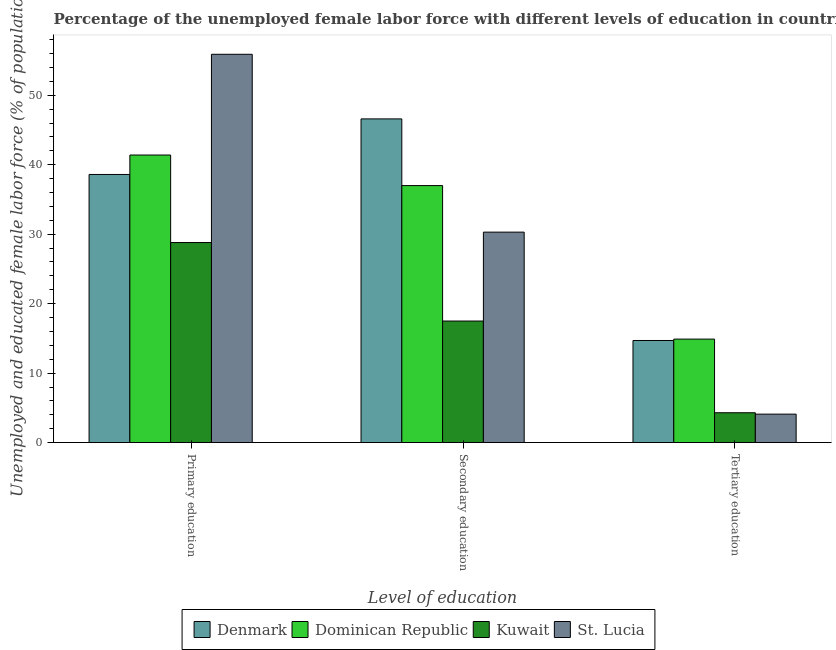Are the number of bars on each tick of the X-axis equal?
Your answer should be compact. Yes. How many bars are there on the 1st tick from the left?
Make the answer very short. 4. How many bars are there on the 2nd tick from the right?
Keep it short and to the point. 4. What is the label of the 3rd group of bars from the left?
Provide a succinct answer. Tertiary education. What is the percentage of female labor force who received tertiary education in Dominican Republic?
Give a very brief answer. 14.9. Across all countries, what is the maximum percentage of female labor force who received tertiary education?
Make the answer very short. 14.9. Across all countries, what is the minimum percentage of female labor force who received tertiary education?
Offer a terse response. 4.1. In which country was the percentage of female labor force who received secondary education maximum?
Your answer should be very brief. Denmark. In which country was the percentage of female labor force who received secondary education minimum?
Give a very brief answer. Kuwait. What is the total percentage of female labor force who received tertiary education in the graph?
Ensure brevity in your answer.  38. What is the difference between the percentage of female labor force who received secondary education in Dominican Republic and that in St. Lucia?
Offer a very short reply. 6.7. What is the difference between the percentage of female labor force who received tertiary education in St. Lucia and the percentage of female labor force who received primary education in Kuwait?
Keep it short and to the point. -24.7. What is the average percentage of female labor force who received secondary education per country?
Make the answer very short. 32.85. What is the difference between the percentage of female labor force who received secondary education and percentage of female labor force who received tertiary education in Dominican Republic?
Offer a very short reply. 22.1. What is the ratio of the percentage of female labor force who received secondary education in Dominican Republic to that in St. Lucia?
Provide a succinct answer. 1.22. What is the difference between the highest and the lowest percentage of female labor force who received tertiary education?
Make the answer very short. 10.8. In how many countries, is the percentage of female labor force who received secondary education greater than the average percentage of female labor force who received secondary education taken over all countries?
Offer a terse response. 2. What does the 4th bar from the right in Tertiary education represents?
Ensure brevity in your answer.  Denmark. Are all the bars in the graph horizontal?
Ensure brevity in your answer.  No. How many countries are there in the graph?
Make the answer very short. 4. Does the graph contain grids?
Your answer should be very brief. No. Where does the legend appear in the graph?
Your answer should be very brief. Bottom center. How many legend labels are there?
Your answer should be very brief. 4. How are the legend labels stacked?
Your answer should be compact. Horizontal. What is the title of the graph?
Provide a short and direct response. Percentage of the unemployed female labor force with different levels of education in countries. What is the label or title of the X-axis?
Offer a very short reply. Level of education. What is the label or title of the Y-axis?
Provide a succinct answer. Unemployed and educated female labor force (% of population). What is the Unemployed and educated female labor force (% of population) in Denmark in Primary education?
Keep it short and to the point. 38.6. What is the Unemployed and educated female labor force (% of population) in Dominican Republic in Primary education?
Provide a short and direct response. 41.4. What is the Unemployed and educated female labor force (% of population) in Kuwait in Primary education?
Ensure brevity in your answer.  28.8. What is the Unemployed and educated female labor force (% of population) in St. Lucia in Primary education?
Keep it short and to the point. 55.9. What is the Unemployed and educated female labor force (% of population) of Denmark in Secondary education?
Your answer should be very brief. 46.6. What is the Unemployed and educated female labor force (% of population) of Dominican Republic in Secondary education?
Provide a succinct answer. 37. What is the Unemployed and educated female labor force (% of population) of St. Lucia in Secondary education?
Your answer should be very brief. 30.3. What is the Unemployed and educated female labor force (% of population) in Denmark in Tertiary education?
Provide a short and direct response. 14.7. What is the Unemployed and educated female labor force (% of population) of Dominican Republic in Tertiary education?
Give a very brief answer. 14.9. What is the Unemployed and educated female labor force (% of population) in Kuwait in Tertiary education?
Provide a short and direct response. 4.3. What is the Unemployed and educated female labor force (% of population) of St. Lucia in Tertiary education?
Provide a short and direct response. 4.1. Across all Level of education, what is the maximum Unemployed and educated female labor force (% of population) of Denmark?
Your answer should be very brief. 46.6. Across all Level of education, what is the maximum Unemployed and educated female labor force (% of population) of Dominican Republic?
Provide a short and direct response. 41.4. Across all Level of education, what is the maximum Unemployed and educated female labor force (% of population) in Kuwait?
Offer a very short reply. 28.8. Across all Level of education, what is the maximum Unemployed and educated female labor force (% of population) in St. Lucia?
Ensure brevity in your answer.  55.9. Across all Level of education, what is the minimum Unemployed and educated female labor force (% of population) in Denmark?
Provide a succinct answer. 14.7. Across all Level of education, what is the minimum Unemployed and educated female labor force (% of population) of Dominican Republic?
Your response must be concise. 14.9. Across all Level of education, what is the minimum Unemployed and educated female labor force (% of population) of Kuwait?
Your answer should be compact. 4.3. Across all Level of education, what is the minimum Unemployed and educated female labor force (% of population) in St. Lucia?
Give a very brief answer. 4.1. What is the total Unemployed and educated female labor force (% of population) in Denmark in the graph?
Give a very brief answer. 99.9. What is the total Unemployed and educated female labor force (% of population) in Dominican Republic in the graph?
Your answer should be very brief. 93.3. What is the total Unemployed and educated female labor force (% of population) in Kuwait in the graph?
Give a very brief answer. 50.6. What is the total Unemployed and educated female labor force (% of population) of St. Lucia in the graph?
Ensure brevity in your answer.  90.3. What is the difference between the Unemployed and educated female labor force (% of population) in Denmark in Primary education and that in Secondary education?
Offer a terse response. -8. What is the difference between the Unemployed and educated female labor force (% of population) in St. Lucia in Primary education and that in Secondary education?
Ensure brevity in your answer.  25.6. What is the difference between the Unemployed and educated female labor force (% of population) of Denmark in Primary education and that in Tertiary education?
Make the answer very short. 23.9. What is the difference between the Unemployed and educated female labor force (% of population) of St. Lucia in Primary education and that in Tertiary education?
Give a very brief answer. 51.8. What is the difference between the Unemployed and educated female labor force (% of population) of Denmark in Secondary education and that in Tertiary education?
Your answer should be compact. 31.9. What is the difference between the Unemployed and educated female labor force (% of population) of Dominican Republic in Secondary education and that in Tertiary education?
Ensure brevity in your answer.  22.1. What is the difference between the Unemployed and educated female labor force (% of population) of St. Lucia in Secondary education and that in Tertiary education?
Offer a terse response. 26.2. What is the difference between the Unemployed and educated female labor force (% of population) of Denmark in Primary education and the Unemployed and educated female labor force (% of population) of Kuwait in Secondary education?
Provide a succinct answer. 21.1. What is the difference between the Unemployed and educated female labor force (% of population) in Denmark in Primary education and the Unemployed and educated female labor force (% of population) in St. Lucia in Secondary education?
Your response must be concise. 8.3. What is the difference between the Unemployed and educated female labor force (% of population) in Dominican Republic in Primary education and the Unemployed and educated female labor force (% of population) in Kuwait in Secondary education?
Provide a short and direct response. 23.9. What is the difference between the Unemployed and educated female labor force (% of population) in Kuwait in Primary education and the Unemployed and educated female labor force (% of population) in St. Lucia in Secondary education?
Your response must be concise. -1.5. What is the difference between the Unemployed and educated female labor force (% of population) in Denmark in Primary education and the Unemployed and educated female labor force (% of population) in Dominican Republic in Tertiary education?
Your response must be concise. 23.7. What is the difference between the Unemployed and educated female labor force (% of population) in Denmark in Primary education and the Unemployed and educated female labor force (% of population) in Kuwait in Tertiary education?
Provide a succinct answer. 34.3. What is the difference between the Unemployed and educated female labor force (% of population) of Denmark in Primary education and the Unemployed and educated female labor force (% of population) of St. Lucia in Tertiary education?
Give a very brief answer. 34.5. What is the difference between the Unemployed and educated female labor force (% of population) in Dominican Republic in Primary education and the Unemployed and educated female labor force (% of population) in Kuwait in Tertiary education?
Your answer should be very brief. 37.1. What is the difference between the Unemployed and educated female labor force (% of population) of Dominican Republic in Primary education and the Unemployed and educated female labor force (% of population) of St. Lucia in Tertiary education?
Offer a terse response. 37.3. What is the difference between the Unemployed and educated female labor force (% of population) of Kuwait in Primary education and the Unemployed and educated female labor force (% of population) of St. Lucia in Tertiary education?
Provide a short and direct response. 24.7. What is the difference between the Unemployed and educated female labor force (% of population) of Denmark in Secondary education and the Unemployed and educated female labor force (% of population) of Dominican Republic in Tertiary education?
Provide a short and direct response. 31.7. What is the difference between the Unemployed and educated female labor force (% of population) of Denmark in Secondary education and the Unemployed and educated female labor force (% of population) of Kuwait in Tertiary education?
Provide a short and direct response. 42.3. What is the difference between the Unemployed and educated female labor force (% of population) of Denmark in Secondary education and the Unemployed and educated female labor force (% of population) of St. Lucia in Tertiary education?
Give a very brief answer. 42.5. What is the difference between the Unemployed and educated female labor force (% of population) of Dominican Republic in Secondary education and the Unemployed and educated female labor force (% of population) of Kuwait in Tertiary education?
Offer a very short reply. 32.7. What is the difference between the Unemployed and educated female labor force (% of population) of Dominican Republic in Secondary education and the Unemployed and educated female labor force (% of population) of St. Lucia in Tertiary education?
Provide a succinct answer. 32.9. What is the difference between the Unemployed and educated female labor force (% of population) in Kuwait in Secondary education and the Unemployed and educated female labor force (% of population) in St. Lucia in Tertiary education?
Offer a very short reply. 13.4. What is the average Unemployed and educated female labor force (% of population) of Denmark per Level of education?
Offer a terse response. 33.3. What is the average Unemployed and educated female labor force (% of population) of Dominican Republic per Level of education?
Offer a terse response. 31.1. What is the average Unemployed and educated female labor force (% of population) in Kuwait per Level of education?
Offer a very short reply. 16.87. What is the average Unemployed and educated female labor force (% of population) of St. Lucia per Level of education?
Your answer should be compact. 30.1. What is the difference between the Unemployed and educated female labor force (% of population) in Denmark and Unemployed and educated female labor force (% of population) in Dominican Republic in Primary education?
Your answer should be very brief. -2.8. What is the difference between the Unemployed and educated female labor force (% of population) in Denmark and Unemployed and educated female labor force (% of population) in St. Lucia in Primary education?
Keep it short and to the point. -17.3. What is the difference between the Unemployed and educated female labor force (% of population) in Dominican Republic and Unemployed and educated female labor force (% of population) in St. Lucia in Primary education?
Your answer should be compact. -14.5. What is the difference between the Unemployed and educated female labor force (% of population) of Kuwait and Unemployed and educated female labor force (% of population) of St. Lucia in Primary education?
Provide a short and direct response. -27.1. What is the difference between the Unemployed and educated female labor force (% of population) in Denmark and Unemployed and educated female labor force (% of population) in Kuwait in Secondary education?
Provide a short and direct response. 29.1. What is the difference between the Unemployed and educated female labor force (% of population) of Denmark and Unemployed and educated female labor force (% of population) of St. Lucia in Secondary education?
Offer a very short reply. 16.3. What is the difference between the Unemployed and educated female labor force (% of population) in Dominican Republic and Unemployed and educated female labor force (% of population) in St. Lucia in Secondary education?
Your response must be concise. 6.7. What is the difference between the Unemployed and educated female labor force (% of population) of Denmark and Unemployed and educated female labor force (% of population) of Dominican Republic in Tertiary education?
Your answer should be compact. -0.2. What is the difference between the Unemployed and educated female labor force (% of population) of Denmark and Unemployed and educated female labor force (% of population) of St. Lucia in Tertiary education?
Your answer should be compact. 10.6. What is the difference between the Unemployed and educated female labor force (% of population) in Dominican Republic and Unemployed and educated female labor force (% of population) in St. Lucia in Tertiary education?
Offer a terse response. 10.8. What is the ratio of the Unemployed and educated female labor force (% of population) of Denmark in Primary education to that in Secondary education?
Ensure brevity in your answer.  0.83. What is the ratio of the Unemployed and educated female labor force (% of population) of Dominican Republic in Primary education to that in Secondary education?
Ensure brevity in your answer.  1.12. What is the ratio of the Unemployed and educated female labor force (% of population) in Kuwait in Primary education to that in Secondary education?
Your answer should be very brief. 1.65. What is the ratio of the Unemployed and educated female labor force (% of population) of St. Lucia in Primary education to that in Secondary education?
Offer a very short reply. 1.84. What is the ratio of the Unemployed and educated female labor force (% of population) in Denmark in Primary education to that in Tertiary education?
Ensure brevity in your answer.  2.63. What is the ratio of the Unemployed and educated female labor force (% of population) of Dominican Republic in Primary education to that in Tertiary education?
Provide a short and direct response. 2.78. What is the ratio of the Unemployed and educated female labor force (% of population) of Kuwait in Primary education to that in Tertiary education?
Provide a short and direct response. 6.7. What is the ratio of the Unemployed and educated female labor force (% of population) in St. Lucia in Primary education to that in Tertiary education?
Your response must be concise. 13.63. What is the ratio of the Unemployed and educated female labor force (% of population) of Denmark in Secondary education to that in Tertiary education?
Offer a very short reply. 3.17. What is the ratio of the Unemployed and educated female labor force (% of population) in Dominican Republic in Secondary education to that in Tertiary education?
Make the answer very short. 2.48. What is the ratio of the Unemployed and educated female labor force (% of population) in Kuwait in Secondary education to that in Tertiary education?
Your response must be concise. 4.07. What is the ratio of the Unemployed and educated female labor force (% of population) of St. Lucia in Secondary education to that in Tertiary education?
Provide a succinct answer. 7.39. What is the difference between the highest and the second highest Unemployed and educated female labor force (% of population) in Denmark?
Give a very brief answer. 8. What is the difference between the highest and the second highest Unemployed and educated female labor force (% of population) in Dominican Republic?
Your response must be concise. 4.4. What is the difference between the highest and the second highest Unemployed and educated female labor force (% of population) of Kuwait?
Your answer should be very brief. 11.3. What is the difference between the highest and the second highest Unemployed and educated female labor force (% of population) in St. Lucia?
Give a very brief answer. 25.6. What is the difference between the highest and the lowest Unemployed and educated female labor force (% of population) of Denmark?
Give a very brief answer. 31.9. What is the difference between the highest and the lowest Unemployed and educated female labor force (% of population) in Dominican Republic?
Provide a short and direct response. 26.5. What is the difference between the highest and the lowest Unemployed and educated female labor force (% of population) of Kuwait?
Your response must be concise. 24.5. What is the difference between the highest and the lowest Unemployed and educated female labor force (% of population) in St. Lucia?
Offer a very short reply. 51.8. 